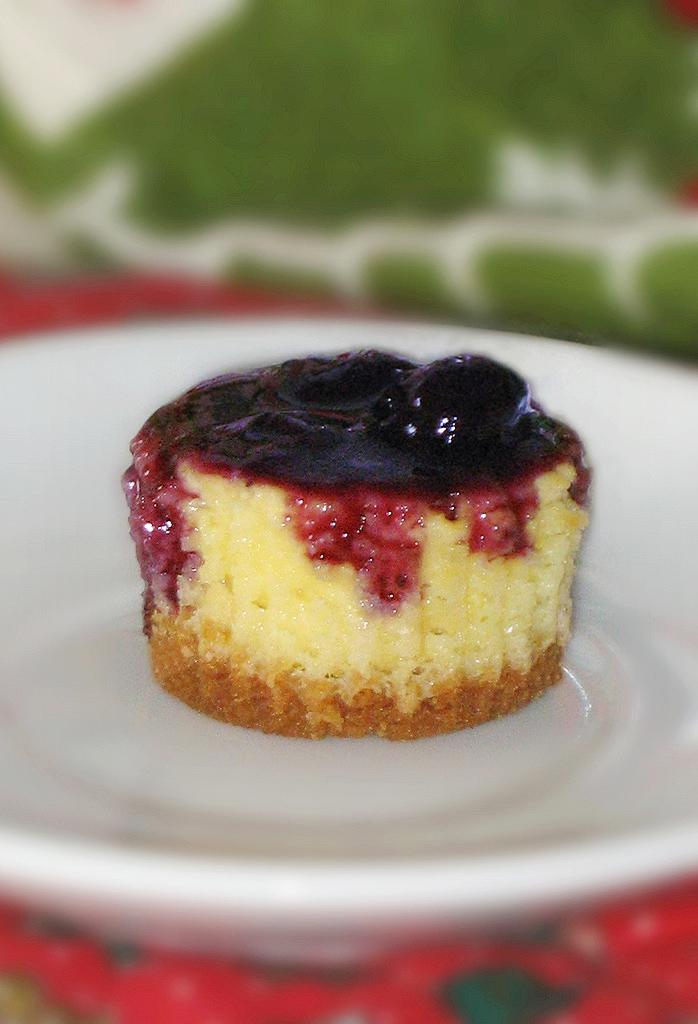What object is present on the plate in the image? There is a cupcake on the plate in the image. What else can be seen on the plate besides the cupcake? There is no other object visible on the plate besides the cupcake. Can you describe the background of the image? The background of the image is blurred. What type of berry is used as bait for the loaf in the image? There is no loaf, berry, or bait present in the image. 